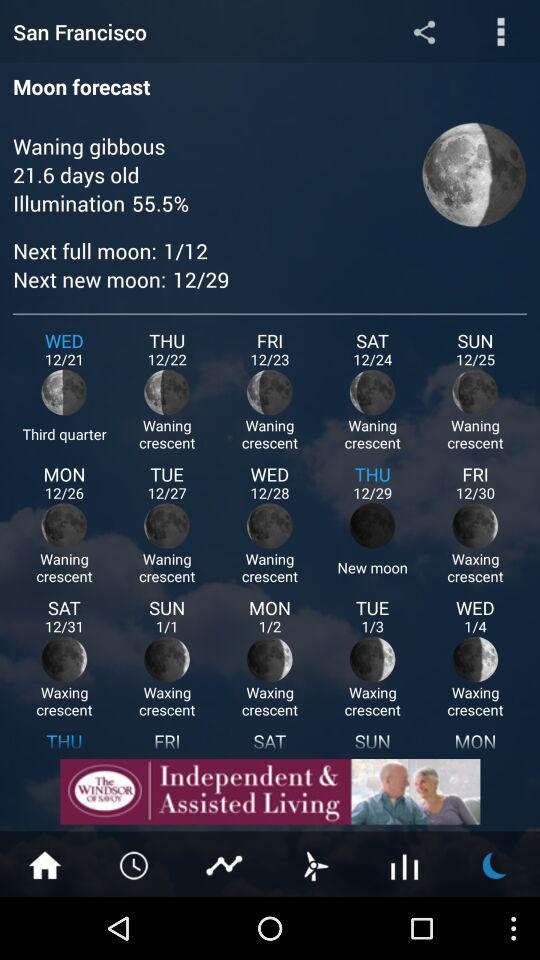What is the percentage for illumination? The percentage is 55.5. 